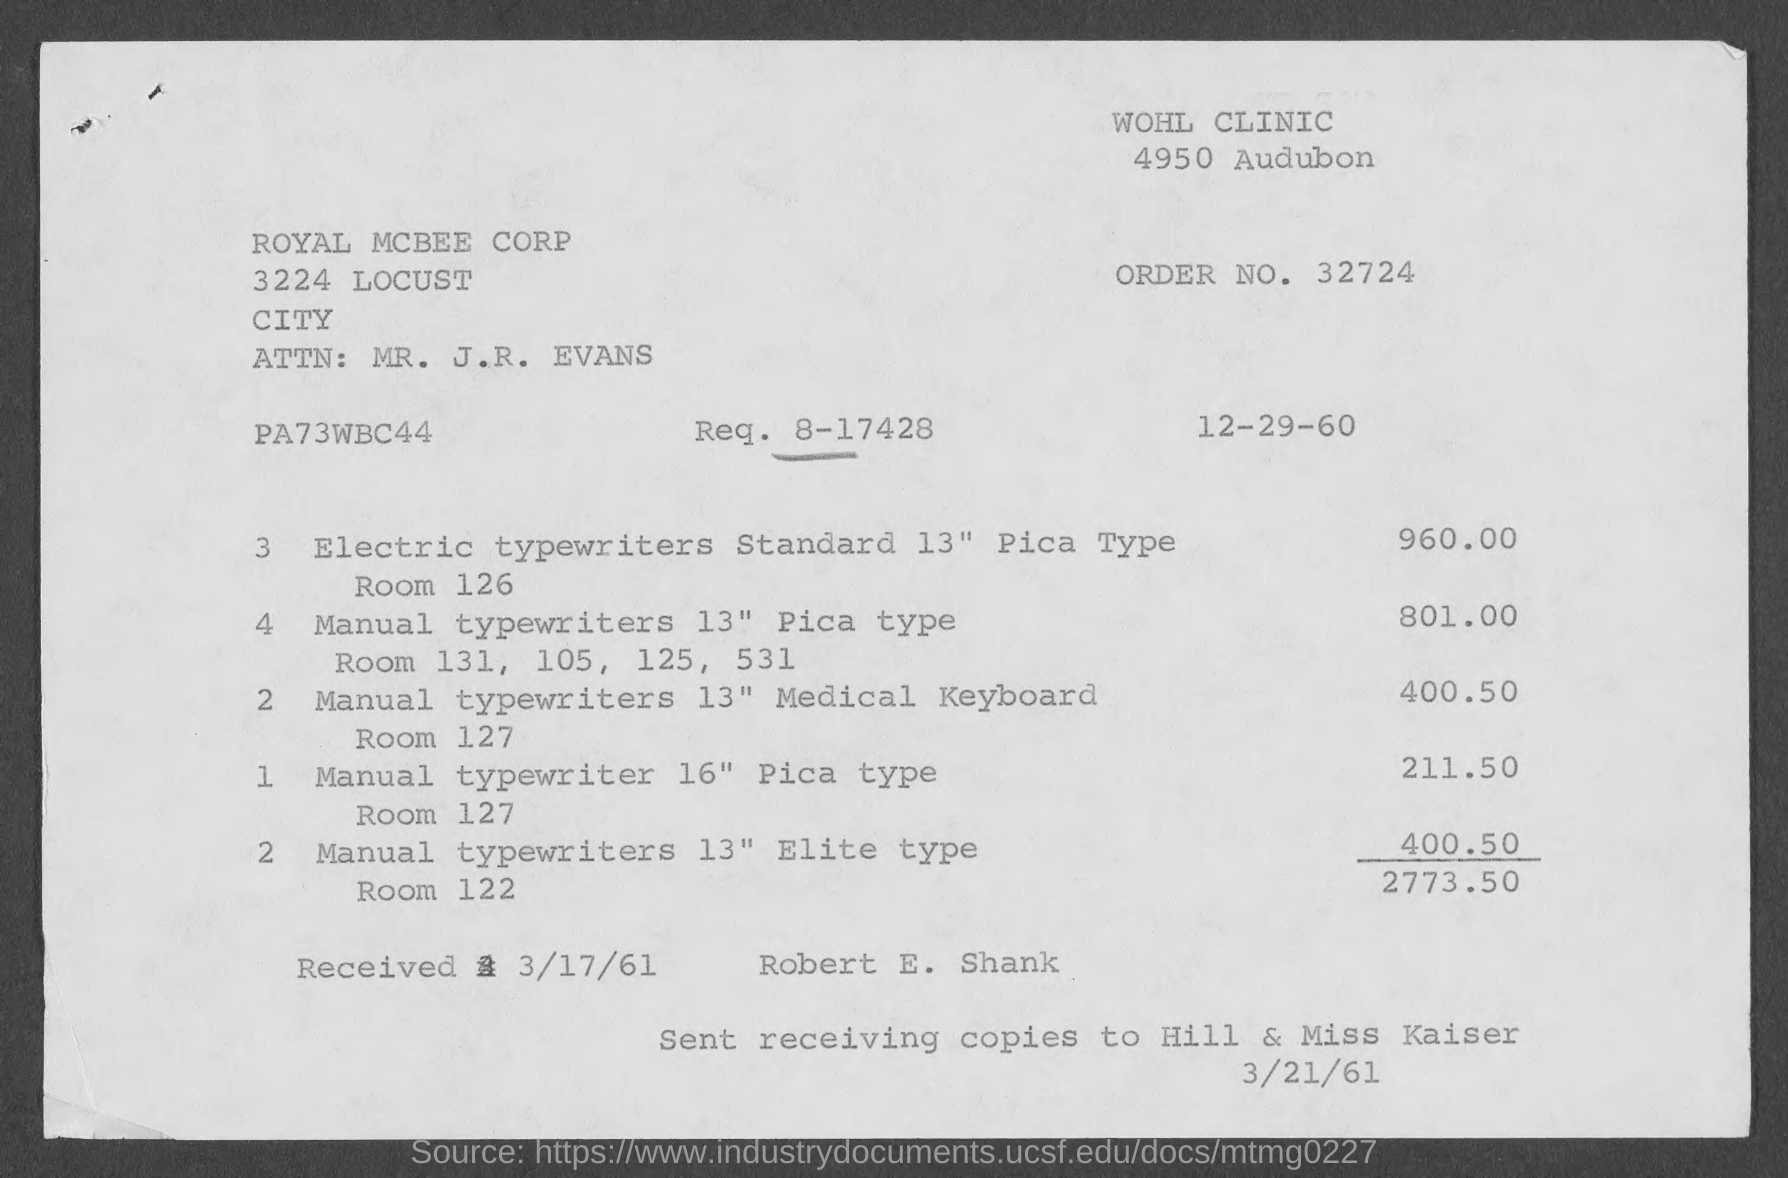What is the issued date of the invoice? The invoice was issued on December 29, 1960. This date is displayed prominently at the top right of the document next to 'Req. No. 8-17428'. 